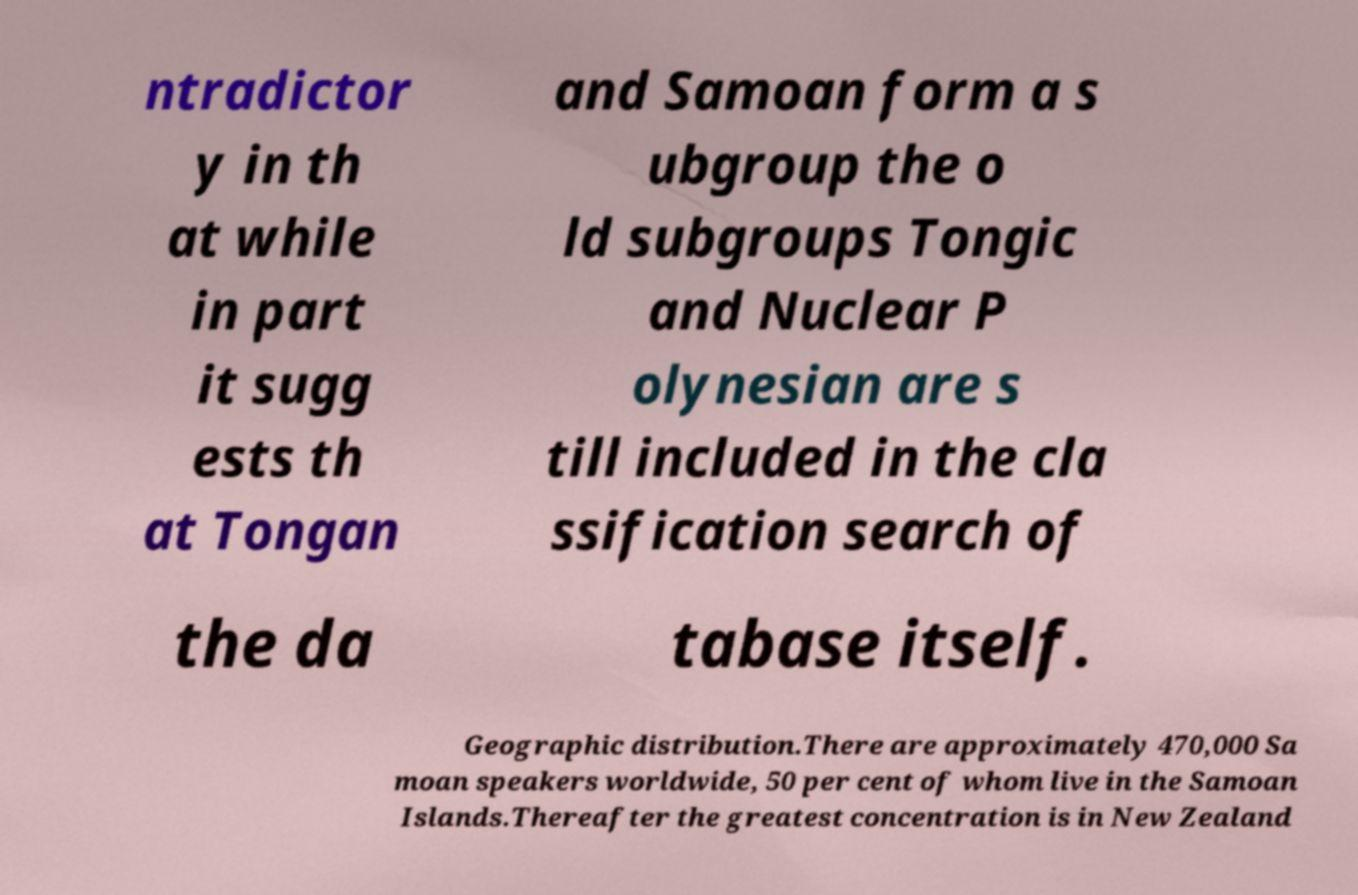Could you assist in decoding the text presented in this image and type it out clearly? ntradictor y in th at while in part it sugg ests th at Tongan and Samoan form a s ubgroup the o ld subgroups Tongic and Nuclear P olynesian are s till included in the cla ssification search of the da tabase itself. Geographic distribution.There are approximately 470,000 Sa moan speakers worldwide, 50 per cent of whom live in the Samoan Islands.Thereafter the greatest concentration is in New Zealand 